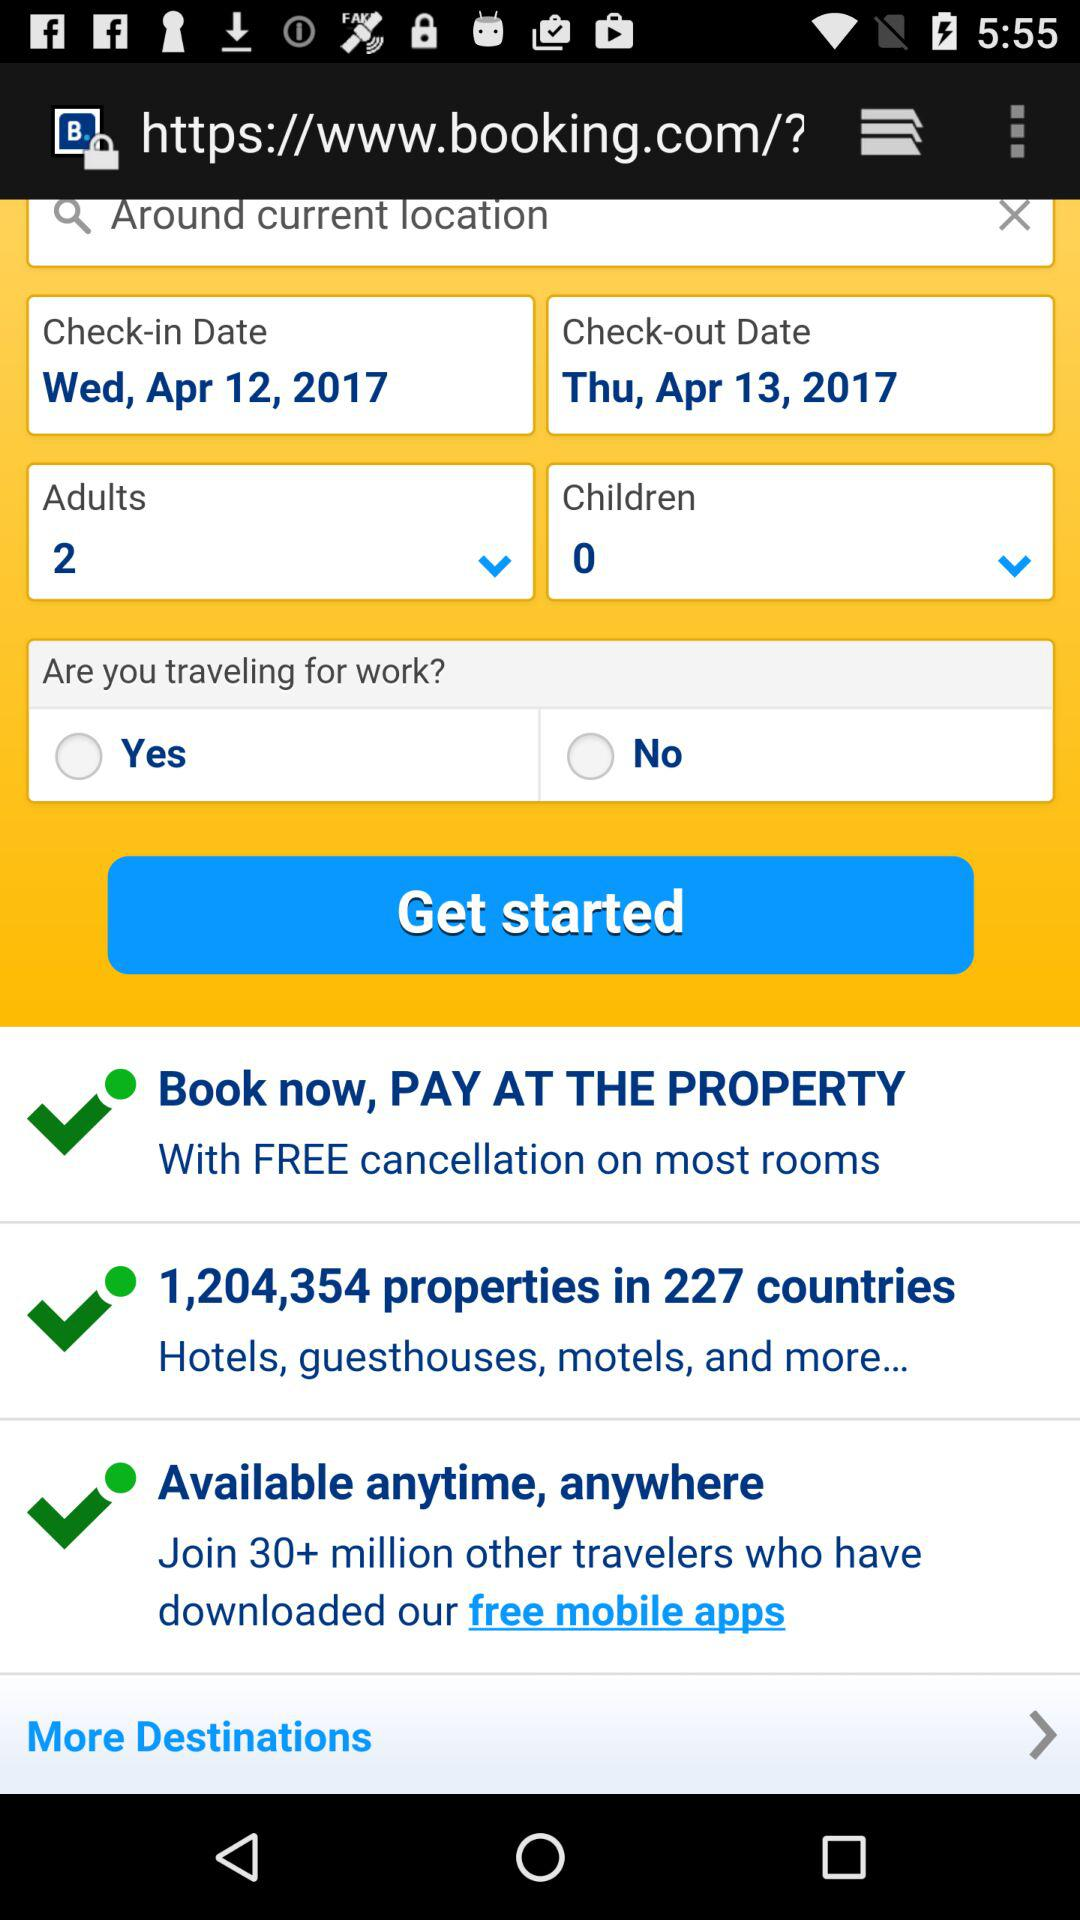How many adults are selected? The number of adults selected is 2. 